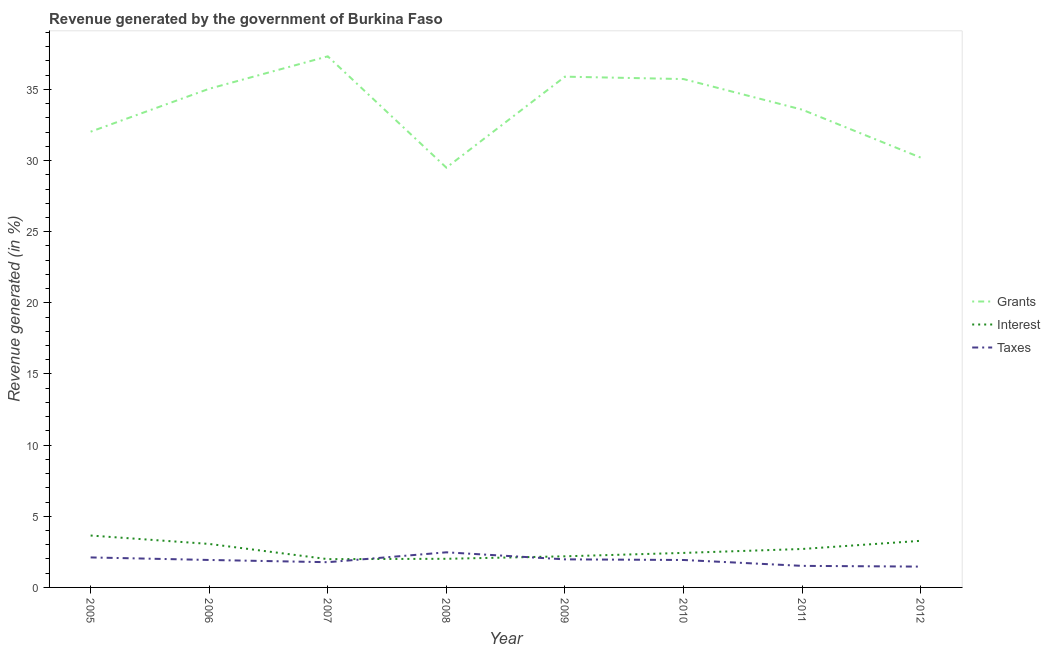How many different coloured lines are there?
Provide a short and direct response. 3. Does the line corresponding to percentage of revenue generated by taxes intersect with the line corresponding to percentage of revenue generated by grants?
Ensure brevity in your answer.  No. What is the percentage of revenue generated by grants in 2005?
Provide a succinct answer. 32.03. Across all years, what is the maximum percentage of revenue generated by taxes?
Ensure brevity in your answer.  2.47. Across all years, what is the minimum percentage of revenue generated by grants?
Make the answer very short. 29.5. In which year was the percentage of revenue generated by interest maximum?
Offer a terse response. 2005. What is the total percentage of revenue generated by taxes in the graph?
Your answer should be compact. 15.16. What is the difference between the percentage of revenue generated by interest in 2006 and that in 2009?
Provide a short and direct response. 0.87. What is the difference between the percentage of revenue generated by grants in 2011 and the percentage of revenue generated by interest in 2006?
Offer a very short reply. 30.52. What is the average percentage of revenue generated by grants per year?
Give a very brief answer. 33.66. In the year 2007, what is the difference between the percentage of revenue generated by interest and percentage of revenue generated by taxes?
Give a very brief answer. 0.21. In how many years, is the percentage of revenue generated by grants greater than 8 %?
Provide a short and direct response. 8. What is the ratio of the percentage of revenue generated by interest in 2010 to that in 2012?
Your answer should be very brief. 0.74. Is the percentage of revenue generated by interest in 2009 less than that in 2010?
Your response must be concise. Yes. Is the difference between the percentage of revenue generated by taxes in 2006 and 2011 greater than the difference between the percentage of revenue generated by interest in 2006 and 2011?
Your response must be concise. Yes. What is the difference between the highest and the second highest percentage of revenue generated by taxes?
Provide a short and direct response. 0.36. What is the difference between the highest and the lowest percentage of revenue generated by taxes?
Keep it short and to the point. 1. Does the percentage of revenue generated by interest monotonically increase over the years?
Ensure brevity in your answer.  No. Is the percentage of revenue generated by taxes strictly greater than the percentage of revenue generated by grants over the years?
Ensure brevity in your answer.  No. Is the percentage of revenue generated by interest strictly less than the percentage of revenue generated by taxes over the years?
Provide a short and direct response. No. How many lines are there?
Provide a short and direct response. 3. What is the difference between two consecutive major ticks on the Y-axis?
Provide a short and direct response. 5. Are the values on the major ticks of Y-axis written in scientific E-notation?
Offer a terse response. No. Does the graph contain grids?
Give a very brief answer. No. Where does the legend appear in the graph?
Offer a very short reply. Center right. How many legend labels are there?
Offer a terse response. 3. How are the legend labels stacked?
Make the answer very short. Vertical. What is the title of the graph?
Offer a terse response. Revenue generated by the government of Burkina Faso. Does "Hydroelectric sources" appear as one of the legend labels in the graph?
Keep it short and to the point. No. What is the label or title of the Y-axis?
Your response must be concise. Revenue generated (in %). What is the Revenue generated (in %) in Grants in 2005?
Provide a succinct answer. 32.03. What is the Revenue generated (in %) in Interest in 2005?
Your response must be concise. 3.65. What is the Revenue generated (in %) in Taxes in 2005?
Your answer should be very brief. 2.11. What is the Revenue generated (in %) of Grants in 2006?
Provide a succinct answer. 35.05. What is the Revenue generated (in %) of Interest in 2006?
Offer a very short reply. 3.06. What is the Revenue generated (in %) in Taxes in 2006?
Your answer should be compact. 1.93. What is the Revenue generated (in %) of Grants in 2007?
Give a very brief answer. 37.32. What is the Revenue generated (in %) of Interest in 2007?
Give a very brief answer. 1.99. What is the Revenue generated (in %) of Taxes in 2007?
Offer a terse response. 1.77. What is the Revenue generated (in %) in Grants in 2008?
Provide a succinct answer. 29.5. What is the Revenue generated (in %) of Interest in 2008?
Your response must be concise. 2.01. What is the Revenue generated (in %) in Taxes in 2008?
Make the answer very short. 2.47. What is the Revenue generated (in %) of Grants in 2009?
Provide a succinct answer. 35.9. What is the Revenue generated (in %) of Interest in 2009?
Provide a succinct answer. 2.19. What is the Revenue generated (in %) in Taxes in 2009?
Make the answer very short. 1.97. What is the Revenue generated (in %) in Grants in 2010?
Ensure brevity in your answer.  35.73. What is the Revenue generated (in %) of Interest in 2010?
Offer a very short reply. 2.43. What is the Revenue generated (in %) of Taxes in 2010?
Your answer should be very brief. 1.93. What is the Revenue generated (in %) in Grants in 2011?
Your answer should be very brief. 33.58. What is the Revenue generated (in %) of Interest in 2011?
Your answer should be very brief. 2.7. What is the Revenue generated (in %) in Taxes in 2011?
Offer a terse response. 1.52. What is the Revenue generated (in %) of Grants in 2012?
Provide a short and direct response. 30.21. What is the Revenue generated (in %) of Interest in 2012?
Make the answer very short. 3.28. What is the Revenue generated (in %) in Taxes in 2012?
Your answer should be very brief. 1.46. Across all years, what is the maximum Revenue generated (in %) in Grants?
Keep it short and to the point. 37.32. Across all years, what is the maximum Revenue generated (in %) of Interest?
Ensure brevity in your answer.  3.65. Across all years, what is the maximum Revenue generated (in %) of Taxes?
Provide a succinct answer. 2.47. Across all years, what is the minimum Revenue generated (in %) of Grants?
Keep it short and to the point. 29.5. Across all years, what is the minimum Revenue generated (in %) of Interest?
Make the answer very short. 1.99. Across all years, what is the minimum Revenue generated (in %) of Taxes?
Make the answer very short. 1.46. What is the total Revenue generated (in %) in Grants in the graph?
Provide a short and direct response. 269.3. What is the total Revenue generated (in %) of Interest in the graph?
Give a very brief answer. 21.29. What is the total Revenue generated (in %) of Taxes in the graph?
Offer a terse response. 15.16. What is the difference between the Revenue generated (in %) in Grants in 2005 and that in 2006?
Keep it short and to the point. -3.02. What is the difference between the Revenue generated (in %) of Interest in 2005 and that in 2006?
Your answer should be compact. 0.59. What is the difference between the Revenue generated (in %) in Taxes in 2005 and that in 2006?
Offer a terse response. 0.18. What is the difference between the Revenue generated (in %) in Grants in 2005 and that in 2007?
Offer a very short reply. -5.3. What is the difference between the Revenue generated (in %) in Interest in 2005 and that in 2007?
Your answer should be very brief. 1.66. What is the difference between the Revenue generated (in %) of Taxes in 2005 and that in 2007?
Give a very brief answer. 0.34. What is the difference between the Revenue generated (in %) in Grants in 2005 and that in 2008?
Give a very brief answer. 2.53. What is the difference between the Revenue generated (in %) of Interest in 2005 and that in 2008?
Make the answer very short. 1.63. What is the difference between the Revenue generated (in %) of Taxes in 2005 and that in 2008?
Provide a short and direct response. -0.36. What is the difference between the Revenue generated (in %) of Grants in 2005 and that in 2009?
Keep it short and to the point. -3.87. What is the difference between the Revenue generated (in %) of Interest in 2005 and that in 2009?
Provide a succinct answer. 1.46. What is the difference between the Revenue generated (in %) in Taxes in 2005 and that in 2009?
Provide a short and direct response. 0.14. What is the difference between the Revenue generated (in %) in Grants in 2005 and that in 2010?
Keep it short and to the point. -3.7. What is the difference between the Revenue generated (in %) of Interest in 2005 and that in 2010?
Provide a succinct answer. 1.22. What is the difference between the Revenue generated (in %) of Taxes in 2005 and that in 2010?
Make the answer very short. 0.18. What is the difference between the Revenue generated (in %) of Grants in 2005 and that in 2011?
Your response must be concise. -1.55. What is the difference between the Revenue generated (in %) of Interest in 2005 and that in 2011?
Provide a short and direct response. 0.95. What is the difference between the Revenue generated (in %) in Taxes in 2005 and that in 2011?
Offer a very short reply. 0.59. What is the difference between the Revenue generated (in %) in Grants in 2005 and that in 2012?
Offer a very short reply. 1.82. What is the difference between the Revenue generated (in %) in Interest in 2005 and that in 2012?
Your response must be concise. 0.37. What is the difference between the Revenue generated (in %) in Taxes in 2005 and that in 2012?
Make the answer very short. 0.65. What is the difference between the Revenue generated (in %) of Grants in 2006 and that in 2007?
Keep it short and to the point. -2.28. What is the difference between the Revenue generated (in %) in Interest in 2006 and that in 2007?
Ensure brevity in your answer.  1.07. What is the difference between the Revenue generated (in %) of Taxes in 2006 and that in 2007?
Provide a succinct answer. 0.16. What is the difference between the Revenue generated (in %) in Grants in 2006 and that in 2008?
Give a very brief answer. 5.55. What is the difference between the Revenue generated (in %) of Interest in 2006 and that in 2008?
Your answer should be very brief. 1.04. What is the difference between the Revenue generated (in %) of Taxes in 2006 and that in 2008?
Provide a succinct answer. -0.54. What is the difference between the Revenue generated (in %) of Grants in 2006 and that in 2009?
Your response must be concise. -0.85. What is the difference between the Revenue generated (in %) in Interest in 2006 and that in 2009?
Offer a terse response. 0.87. What is the difference between the Revenue generated (in %) in Taxes in 2006 and that in 2009?
Provide a short and direct response. -0.04. What is the difference between the Revenue generated (in %) of Grants in 2006 and that in 2010?
Offer a very short reply. -0.68. What is the difference between the Revenue generated (in %) in Interest in 2006 and that in 2010?
Your response must be concise. 0.63. What is the difference between the Revenue generated (in %) in Taxes in 2006 and that in 2010?
Offer a very short reply. 0. What is the difference between the Revenue generated (in %) of Grants in 2006 and that in 2011?
Keep it short and to the point. 1.47. What is the difference between the Revenue generated (in %) of Interest in 2006 and that in 2011?
Make the answer very short. 0.35. What is the difference between the Revenue generated (in %) in Taxes in 2006 and that in 2011?
Offer a terse response. 0.41. What is the difference between the Revenue generated (in %) in Grants in 2006 and that in 2012?
Offer a very short reply. 4.84. What is the difference between the Revenue generated (in %) of Interest in 2006 and that in 2012?
Your answer should be compact. -0.22. What is the difference between the Revenue generated (in %) in Taxes in 2006 and that in 2012?
Your answer should be very brief. 0.47. What is the difference between the Revenue generated (in %) in Grants in 2007 and that in 2008?
Ensure brevity in your answer.  7.82. What is the difference between the Revenue generated (in %) of Interest in 2007 and that in 2008?
Your response must be concise. -0.02. What is the difference between the Revenue generated (in %) of Taxes in 2007 and that in 2008?
Provide a succinct answer. -0.69. What is the difference between the Revenue generated (in %) of Grants in 2007 and that in 2009?
Provide a short and direct response. 1.43. What is the difference between the Revenue generated (in %) of Interest in 2007 and that in 2009?
Keep it short and to the point. -0.2. What is the difference between the Revenue generated (in %) in Taxes in 2007 and that in 2009?
Your answer should be very brief. -0.2. What is the difference between the Revenue generated (in %) in Grants in 2007 and that in 2010?
Make the answer very short. 1.6. What is the difference between the Revenue generated (in %) in Interest in 2007 and that in 2010?
Give a very brief answer. -0.44. What is the difference between the Revenue generated (in %) in Taxes in 2007 and that in 2010?
Offer a very short reply. -0.16. What is the difference between the Revenue generated (in %) in Grants in 2007 and that in 2011?
Offer a terse response. 3.75. What is the difference between the Revenue generated (in %) of Interest in 2007 and that in 2011?
Your response must be concise. -0.71. What is the difference between the Revenue generated (in %) in Taxes in 2007 and that in 2011?
Your response must be concise. 0.26. What is the difference between the Revenue generated (in %) of Grants in 2007 and that in 2012?
Your response must be concise. 7.12. What is the difference between the Revenue generated (in %) of Interest in 2007 and that in 2012?
Offer a very short reply. -1.29. What is the difference between the Revenue generated (in %) in Taxes in 2007 and that in 2012?
Keep it short and to the point. 0.31. What is the difference between the Revenue generated (in %) in Grants in 2008 and that in 2009?
Offer a terse response. -6.39. What is the difference between the Revenue generated (in %) in Interest in 2008 and that in 2009?
Provide a succinct answer. -0.17. What is the difference between the Revenue generated (in %) of Taxes in 2008 and that in 2009?
Your answer should be very brief. 0.49. What is the difference between the Revenue generated (in %) in Grants in 2008 and that in 2010?
Give a very brief answer. -6.23. What is the difference between the Revenue generated (in %) of Interest in 2008 and that in 2010?
Your response must be concise. -0.41. What is the difference between the Revenue generated (in %) in Taxes in 2008 and that in 2010?
Keep it short and to the point. 0.54. What is the difference between the Revenue generated (in %) of Grants in 2008 and that in 2011?
Offer a very short reply. -4.08. What is the difference between the Revenue generated (in %) in Interest in 2008 and that in 2011?
Offer a very short reply. -0.69. What is the difference between the Revenue generated (in %) in Taxes in 2008 and that in 2011?
Offer a terse response. 0.95. What is the difference between the Revenue generated (in %) of Grants in 2008 and that in 2012?
Make the answer very short. -0.71. What is the difference between the Revenue generated (in %) in Interest in 2008 and that in 2012?
Ensure brevity in your answer.  -1.26. What is the difference between the Revenue generated (in %) in Taxes in 2008 and that in 2012?
Keep it short and to the point. 1. What is the difference between the Revenue generated (in %) of Grants in 2009 and that in 2010?
Provide a short and direct response. 0.17. What is the difference between the Revenue generated (in %) of Interest in 2009 and that in 2010?
Your response must be concise. -0.24. What is the difference between the Revenue generated (in %) of Taxes in 2009 and that in 2010?
Your answer should be compact. 0.04. What is the difference between the Revenue generated (in %) of Grants in 2009 and that in 2011?
Give a very brief answer. 2.32. What is the difference between the Revenue generated (in %) of Interest in 2009 and that in 2011?
Provide a succinct answer. -0.51. What is the difference between the Revenue generated (in %) of Taxes in 2009 and that in 2011?
Provide a short and direct response. 0.46. What is the difference between the Revenue generated (in %) of Grants in 2009 and that in 2012?
Keep it short and to the point. 5.69. What is the difference between the Revenue generated (in %) of Interest in 2009 and that in 2012?
Make the answer very short. -1.09. What is the difference between the Revenue generated (in %) of Taxes in 2009 and that in 2012?
Keep it short and to the point. 0.51. What is the difference between the Revenue generated (in %) in Grants in 2010 and that in 2011?
Provide a succinct answer. 2.15. What is the difference between the Revenue generated (in %) of Interest in 2010 and that in 2011?
Your response must be concise. -0.28. What is the difference between the Revenue generated (in %) of Taxes in 2010 and that in 2011?
Provide a short and direct response. 0.41. What is the difference between the Revenue generated (in %) of Grants in 2010 and that in 2012?
Make the answer very short. 5.52. What is the difference between the Revenue generated (in %) in Interest in 2010 and that in 2012?
Offer a terse response. -0.85. What is the difference between the Revenue generated (in %) in Taxes in 2010 and that in 2012?
Ensure brevity in your answer.  0.47. What is the difference between the Revenue generated (in %) of Grants in 2011 and that in 2012?
Your response must be concise. 3.37. What is the difference between the Revenue generated (in %) in Interest in 2011 and that in 2012?
Your answer should be very brief. -0.57. What is the difference between the Revenue generated (in %) of Taxes in 2011 and that in 2012?
Make the answer very short. 0.05. What is the difference between the Revenue generated (in %) of Grants in 2005 and the Revenue generated (in %) of Interest in 2006?
Provide a succinct answer. 28.97. What is the difference between the Revenue generated (in %) in Grants in 2005 and the Revenue generated (in %) in Taxes in 2006?
Your response must be concise. 30.1. What is the difference between the Revenue generated (in %) of Interest in 2005 and the Revenue generated (in %) of Taxes in 2006?
Offer a very short reply. 1.72. What is the difference between the Revenue generated (in %) of Grants in 2005 and the Revenue generated (in %) of Interest in 2007?
Ensure brevity in your answer.  30.04. What is the difference between the Revenue generated (in %) of Grants in 2005 and the Revenue generated (in %) of Taxes in 2007?
Your answer should be very brief. 30.25. What is the difference between the Revenue generated (in %) in Interest in 2005 and the Revenue generated (in %) in Taxes in 2007?
Your response must be concise. 1.87. What is the difference between the Revenue generated (in %) in Grants in 2005 and the Revenue generated (in %) in Interest in 2008?
Your answer should be compact. 30.02. What is the difference between the Revenue generated (in %) of Grants in 2005 and the Revenue generated (in %) of Taxes in 2008?
Your response must be concise. 29.56. What is the difference between the Revenue generated (in %) of Interest in 2005 and the Revenue generated (in %) of Taxes in 2008?
Provide a short and direct response. 1.18. What is the difference between the Revenue generated (in %) of Grants in 2005 and the Revenue generated (in %) of Interest in 2009?
Keep it short and to the point. 29.84. What is the difference between the Revenue generated (in %) of Grants in 2005 and the Revenue generated (in %) of Taxes in 2009?
Keep it short and to the point. 30.05. What is the difference between the Revenue generated (in %) in Interest in 2005 and the Revenue generated (in %) in Taxes in 2009?
Your answer should be compact. 1.67. What is the difference between the Revenue generated (in %) of Grants in 2005 and the Revenue generated (in %) of Interest in 2010?
Your answer should be very brief. 29.6. What is the difference between the Revenue generated (in %) of Grants in 2005 and the Revenue generated (in %) of Taxes in 2010?
Provide a succinct answer. 30.1. What is the difference between the Revenue generated (in %) in Interest in 2005 and the Revenue generated (in %) in Taxes in 2010?
Make the answer very short. 1.72. What is the difference between the Revenue generated (in %) in Grants in 2005 and the Revenue generated (in %) in Interest in 2011?
Your answer should be compact. 29.33. What is the difference between the Revenue generated (in %) of Grants in 2005 and the Revenue generated (in %) of Taxes in 2011?
Provide a succinct answer. 30.51. What is the difference between the Revenue generated (in %) of Interest in 2005 and the Revenue generated (in %) of Taxes in 2011?
Keep it short and to the point. 2.13. What is the difference between the Revenue generated (in %) in Grants in 2005 and the Revenue generated (in %) in Interest in 2012?
Give a very brief answer. 28.75. What is the difference between the Revenue generated (in %) of Grants in 2005 and the Revenue generated (in %) of Taxes in 2012?
Give a very brief answer. 30.56. What is the difference between the Revenue generated (in %) of Interest in 2005 and the Revenue generated (in %) of Taxes in 2012?
Give a very brief answer. 2.18. What is the difference between the Revenue generated (in %) of Grants in 2006 and the Revenue generated (in %) of Interest in 2007?
Ensure brevity in your answer.  33.06. What is the difference between the Revenue generated (in %) of Grants in 2006 and the Revenue generated (in %) of Taxes in 2007?
Ensure brevity in your answer.  33.27. What is the difference between the Revenue generated (in %) in Interest in 2006 and the Revenue generated (in %) in Taxes in 2007?
Provide a short and direct response. 1.28. What is the difference between the Revenue generated (in %) in Grants in 2006 and the Revenue generated (in %) in Interest in 2008?
Provide a succinct answer. 33.03. What is the difference between the Revenue generated (in %) of Grants in 2006 and the Revenue generated (in %) of Taxes in 2008?
Give a very brief answer. 32.58. What is the difference between the Revenue generated (in %) of Interest in 2006 and the Revenue generated (in %) of Taxes in 2008?
Provide a short and direct response. 0.59. What is the difference between the Revenue generated (in %) in Grants in 2006 and the Revenue generated (in %) in Interest in 2009?
Offer a terse response. 32.86. What is the difference between the Revenue generated (in %) in Grants in 2006 and the Revenue generated (in %) in Taxes in 2009?
Make the answer very short. 33.07. What is the difference between the Revenue generated (in %) of Interest in 2006 and the Revenue generated (in %) of Taxes in 2009?
Your response must be concise. 1.08. What is the difference between the Revenue generated (in %) of Grants in 2006 and the Revenue generated (in %) of Interest in 2010?
Your answer should be very brief. 32.62. What is the difference between the Revenue generated (in %) in Grants in 2006 and the Revenue generated (in %) in Taxes in 2010?
Ensure brevity in your answer.  33.12. What is the difference between the Revenue generated (in %) of Interest in 2006 and the Revenue generated (in %) of Taxes in 2010?
Keep it short and to the point. 1.13. What is the difference between the Revenue generated (in %) in Grants in 2006 and the Revenue generated (in %) in Interest in 2011?
Keep it short and to the point. 32.34. What is the difference between the Revenue generated (in %) in Grants in 2006 and the Revenue generated (in %) in Taxes in 2011?
Make the answer very short. 33.53. What is the difference between the Revenue generated (in %) in Interest in 2006 and the Revenue generated (in %) in Taxes in 2011?
Provide a succinct answer. 1.54. What is the difference between the Revenue generated (in %) of Grants in 2006 and the Revenue generated (in %) of Interest in 2012?
Your answer should be compact. 31.77. What is the difference between the Revenue generated (in %) in Grants in 2006 and the Revenue generated (in %) in Taxes in 2012?
Offer a very short reply. 33.58. What is the difference between the Revenue generated (in %) in Interest in 2006 and the Revenue generated (in %) in Taxes in 2012?
Give a very brief answer. 1.59. What is the difference between the Revenue generated (in %) in Grants in 2007 and the Revenue generated (in %) in Interest in 2008?
Offer a terse response. 35.31. What is the difference between the Revenue generated (in %) in Grants in 2007 and the Revenue generated (in %) in Taxes in 2008?
Offer a terse response. 34.86. What is the difference between the Revenue generated (in %) in Interest in 2007 and the Revenue generated (in %) in Taxes in 2008?
Make the answer very short. -0.48. What is the difference between the Revenue generated (in %) in Grants in 2007 and the Revenue generated (in %) in Interest in 2009?
Provide a succinct answer. 35.14. What is the difference between the Revenue generated (in %) in Grants in 2007 and the Revenue generated (in %) in Taxes in 2009?
Provide a short and direct response. 35.35. What is the difference between the Revenue generated (in %) in Interest in 2007 and the Revenue generated (in %) in Taxes in 2009?
Your answer should be very brief. 0.01. What is the difference between the Revenue generated (in %) of Grants in 2007 and the Revenue generated (in %) of Interest in 2010?
Keep it short and to the point. 34.9. What is the difference between the Revenue generated (in %) of Grants in 2007 and the Revenue generated (in %) of Taxes in 2010?
Your answer should be compact. 35.4. What is the difference between the Revenue generated (in %) of Interest in 2007 and the Revenue generated (in %) of Taxes in 2010?
Your answer should be compact. 0.06. What is the difference between the Revenue generated (in %) of Grants in 2007 and the Revenue generated (in %) of Interest in 2011?
Ensure brevity in your answer.  34.62. What is the difference between the Revenue generated (in %) in Grants in 2007 and the Revenue generated (in %) in Taxes in 2011?
Your response must be concise. 35.81. What is the difference between the Revenue generated (in %) in Interest in 2007 and the Revenue generated (in %) in Taxes in 2011?
Provide a succinct answer. 0.47. What is the difference between the Revenue generated (in %) of Grants in 2007 and the Revenue generated (in %) of Interest in 2012?
Your answer should be compact. 34.05. What is the difference between the Revenue generated (in %) of Grants in 2007 and the Revenue generated (in %) of Taxes in 2012?
Give a very brief answer. 35.86. What is the difference between the Revenue generated (in %) of Interest in 2007 and the Revenue generated (in %) of Taxes in 2012?
Offer a very short reply. 0.52. What is the difference between the Revenue generated (in %) of Grants in 2008 and the Revenue generated (in %) of Interest in 2009?
Your answer should be very brief. 27.31. What is the difference between the Revenue generated (in %) in Grants in 2008 and the Revenue generated (in %) in Taxes in 2009?
Make the answer very short. 27.53. What is the difference between the Revenue generated (in %) in Interest in 2008 and the Revenue generated (in %) in Taxes in 2009?
Offer a terse response. 0.04. What is the difference between the Revenue generated (in %) of Grants in 2008 and the Revenue generated (in %) of Interest in 2010?
Provide a succinct answer. 27.07. What is the difference between the Revenue generated (in %) in Grants in 2008 and the Revenue generated (in %) in Taxes in 2010?
Keep it short and to the point. 27.57. What is the difference between the Revenue generated (in %) in Interest in 2008 and the Revenue generated (in %) in Taxes in 2010?
Your answer should be compact. 0.08. What is the difference between the Revenue generated (in %) of Grants in 2008 and the Revenue generated (in %) of Interest in 2011?
Give a very brief answer. 26.8. What is the difference between the Revenue generated (in %) of Grants in 2008 and the Revenue generated (in %) of Taxes in 2011?
Keep it short and to the point. 27.99. What is the difference between the Revenue generated (in %) of Interest in 2008 and the Revenue generated (in %) of Taxes in 2011?
Give a very brief answer. 0.5. What is the difference between the Revenue generated (in %) of Grants in 2008 and the Revenue generated (in %) of Interest in 2012?
Your answer should be very brief. 26.23. What is the difference between the Revenue generated (in %) in Grants in 2008 and the Revenue generated (in %) in Taxes in 2012?
Keep it short and to the point. 28.04. What is the difference between the Revenue generated (in %) in Interest in 2008 and the Revenue generated (in %) in Taxes in 2012?
Keep it short and to the point. 0.55. What is the difference between the Revenue generated (in %) in Grants in 2009 and the Revenue generated (in %) in Interest in 2010?
Your response must be concise. 33.47. What is the difference between the Revenue generated (in %) in Grants in 2009 and the Revenue generated (in %) in Taxes in 2010?
Offer a very short reply. 33.97. What is the difference between the Revenue generated (in %) of Interest in 2009 and the Revenue generated (in %) of Taxes in 2010?
Offer a terse response. 0.26. What is the difference between the Revenue generated (in %) in Grants in 2009 and the Revenue generated (in %) in Interest in 2011?
Keep it short and to the point. 33.19. What is the difference between the Revenue generated (in %) of Grants in 2009 and the Revenue generated (in %) of Taxes in 2011?
Offer a terse response. 34.38. What is the difference between the Revenue generated (in %) of Interest in 2009 and the Revenue generated (in %) of Taxes in 2011?
Offer a very short reply. 0.67. What is the difference between the Revenue generated (in %) in Grants in 2009 and the Revenue generated (in %) in Interest in 2012?
Provide a short and direct response. 32.62. What is the difference between the Revenue generated (in %) of Grants in 2009 and the Revenue generated (in %) of Taxes in 2012?
Keep it short and to the point. 34.43. What is the difference between the Revenue generated (in %) of Interest in 2009 and the Revenue generated (in %) of Taxes in 2012?
Give a very brief answer. 0.72. What is the difference between the Revenue generated (in %) in Grants in 2010 and the Revenue generated (in %) in Interest in 2011?
Provide a succinct answer. 33.02. What is the difference between the Revenue generated (in %) in Grants in 2010 and the Revenue generated (in %) in Taxes in 2011?
Your answer should be compact. 34.21. What is the difference between the Revenue generated (in %) of Interest in 2010 and the Revenue generated (in %) of Taxes in 2011?
Provide a short and direct response. 0.91. What is the difference between the Revenue generated (in %) in Grants in 2010 and the Revenue generated (in %) in Interest in 2012?
Keep it short and to the point. 32.45. What is the difference between the Revenue generated (in %) in Grants in 2010 and the Revenue generated (in %) in Taxes in 2012?
Your answer should be very brief. 34.26. What is the difference between the Revenue generated (in %) in Interest in 2010 and the Revenue generated (in %) in Taxes in 2012?
Offer a very short reply. 0.96. What is the difference between the Revenue generated (in %) of Grants in 2011 and the Revenue generated (in %) of Interest in 2012?
Make the answer very short. 30.3. What is the difference between the Revenue generated (in %) of Grants in 2011 and the Revenue generated (in %) of Taxes in 2012?
Offer a terse response. 32.11. What is the difference between the Revenue generated (in %) in Interest in 2011 and the Revenue generated (in %) in Taxes in 2012?
Offer a terse response. 1.24. What is the average Revenue generated (in %) of Grants per year?
Keep it short and to the point. 33.66. What is the average Revenue generated (in %) in Interest per year?
Make the answer very short. 2.66. What is the average Revenue generated (in %) in Taxes per year?
Make the answer very short. 1.89. In the year 2005, what is the difference between the Revenue generated (in %) of Grants and Revenue generated (in %) of Interest?
Provide a succinct answer. 28.38. In the year 2005, what is the difference between the Revenue generated (in %) in Grants and Revenue generated (in %) in Taxes?
Keep it short and to the point. 29.92. In the year 2005, what is the difference between the Revenue generated (in %) of Interest and Revenue generated (in %) of Taxes?
Make the answer very short. 1.54. In the year 2006, what is the difference between the Revenue generated (in %) in Grants and Revenue generated (in %) in Interest?
Offer a very short reply. 31.99. In the year 2006, what is the difference between the Revenue generated (in %) in Grants and Revenue generated (in %) in Taxes?
Provide a succinct answer. 33.12. In the year 2006, what is the difference between the Revenue generated (in %) in Interest and Revenue generated (in %) in Taxes?
Keep it short and to the point. 1.13. In the year 2007, what is the difference between the Revenue generated (in %) of Grants and Revenue generated (in %) of Interest?
Keep it short and to the point. 35.34. In the year 2007, what is the difference between the Revenue generated (in %) in Grants and Revenue generated (in %) in Taxes?
Provide a succinct answer. 35.55. In the year 2007, what is the difference between the Revenue generated (in %) in Interest and Revenue generated (in %) in Taxes?
Provide a short and direct response. 0.21. In the year 2008, what is the difference between the Revenue generated (in %) in Grants and Revenue generated (in %) in Interest?
Give a very brief answer. 27.49. In the year 2008, what is the difference between the Revenue generated (in %) of Grants and Revenue generated (in %) of Taxes?
Provide a succinct answer. 27.03. In the year 2008, what is the difference between the Revenue generated (in %) in Interest and Revenue generated (in %) in Taxes?
Your response must be concise. -0.46. In the year 2009, what is the difference between the Revenue generated (in %) in Grants and Revenue generated (in %) in Interest?
Provide a short and direct response. 33.71. In the year 2009, what is the difference between the Revenue generated (in %) of Grants and Revenue generated (in %) of Taxes?
Your answer should be very brief. 33.92. In the year 2009, what is the difference between the Revenue generated (in %) of Interest and Revenue generated (in %) of Taxes?
Keep it short and to the point. 0.21. In the year 2010, what is the difference between the Revenue generated (in %) of Grants and Revenue generated (in %) of Interest?
Your response must be concise. 33.3. In the year 2010, what is the difference between the Revenue generated (in %) in Grants and Revenue generated (in %) in Taxes?
Make the answer very short. 33.8. In the year 2010, what is the difference between the Revenue generated (in %) in Interest and Revenue generated (in %) in Taxes?
Provide a succinct answer. 0.5. In the year 2011, what is the difference between the Revenue generated (in %) of Grants and Revenue generated (in %) of Interest?
Your answer should be compact. 30.88. In the year 2011, what is the difference between the Revenue generated (in %) of Grants and Revenue generated (in %) of Taxes?
Your answer should be compact. 32.06. In the year 2011, what is the difference between the Revenue generated (in %) in Interest and Revenue generated (in %) in Taxes?
Your answer should be very brief. 1.19. In the year 2012, what is the difference between the Revenue generated (in %) in Grants and Revenue generated (in %) in Interest?
Keep it short and to the point. 26.93. In the year 2012, what is the difference between the Revenue generated (in %) of Grants and Revenue generated (in %) of Taxes?
Offer a terse response. 28.74. In the year 2012, what is the difference between the Revenue generated (in %) in Interest and Revenue generated (in %) in Taxes?
Your answer should be very brief. 1.81. What is the ratio of the Revenue generated (in %) in Grants in 2005 to that in 2006?
Provide a succinct answer. 0.91. What is the ratio of the Revenue generated (in %) in Interest in 2005 to that in 2006?
Offer a very short reply. 1.19. What is the ratio of the Revenue generated (in %) of Taxes in 2005 to that in 2006?
Keep it short and to the point. 1.09. What is the ratio of the Revenue generated (in %) of Grants in 2005 to that in 2007?
Keep it short and to the point. 0.86. What is the ratio of the Revenue generated (in %) in Interest in 2005 to that in 2007?
Offer a terse response. 1.83. What is the ratio of the Revenue generated (in %) of Taxes in 2005 to that in 2007?
Ensure brevity in your answer.  1.19. What is the ratio of the Revenue generated (in %) in Grants in 2005 to that in 2008?
Provide a succinct answer. 1.09. What is the ratio of the Revenue generated (in %) in Interest in 2005 to that in 2008?
Give a very brief answer. 1.81. What is the ratio of the Revenue generated (in %) in Taxes in 2005 to that in 2008?
Keep it short and to the point. 0.85. What is the ratio of the Revenue generated (in %) of Grants in 2005 to that in 2009?
Make the answer very short. 0.89. What is the ratio of the Revenue generated (in %) in Interest in 2005 to that in 2009?
Your response must be concise. 1.67. What is the ratio of the Revenue generated (in %) of Taxes in 2005 to that in 2009?
Provide a succinct answer. 1.07. What is the ratio of the Revenue generated (in %) in Grants in 2005 to that in 2010?
Give a very brief answer. 0.9. What is the ratio of the Revenue generated (in %) of Interest in 2005 to that in 2010?
Ensure brevity in your answer.  1.5. What is the ratio of the Revenue generated (in %) of Taxes in 2005 to that in 2010?
Make the answer very short. 1.09. What is the ratio of the Revenue generated (in %) of Grants in 2005 to that in 2011?
Ensure brevity in your answer.  0.95. What is the ratio of the Revenue generated (in %) in Interest in 2005 to that in 2011?
Your answer should be very brief. 1.35. What is the ratio of the Revenue generated (in %) in Taxes in 2005 to that in 2011?
Keep it short and to the point. 1.39. What is the ratio of the Revenue generated (in %) of Grants in 2005 to that in 2012?
Offer a terse response. 1.06. What is the ratio of the Revenue generated (in %) in Interest in 2005 to that in 2012?
Make the answer very short. 1.11. What is the ratio of the Revenue generated (in %) of Taxes in 2005 to that in 2012?
Provide a succinct answer. 1.44. What is the ratio of the Revenue generated (in %) in Grants in 2006 to that in 2007?
Keep it short and to the point. 0.94. What is the ratio of the Revenue generated (in %) in Interest in 2006 to that in 2007?
Offer a terse response. 1.54. What is the ratio of the Revenue generated (in %) of Taxes in 2006 to that in 2007?
Provide a succinct answer. 1.09. What is the ratio of the Revenue generated (in %) in Grants in 2006 to that in 2008?
Provide a succinct answer. 1.19. What is the ratio of the Revenue generated (in %) in Interest in 2006 to that in 2008?
Keep it short and to the point. 1.52. What is the ratio of the Revenue generated (in %) of Taxes in 2006 to that in 2008?
Offer a terse response. 0.78. What is the ratio of the Revenue generated (in %) of Grants in 2006 to that in 2009?
Provide a short and direct response. 0.98. What is the ratio of the Revenue generated (in %) of Interest in 2006 to that in 2009?
Offer a terse response. 1.4. What is the ratio of the Revenue generated (in %) in Taxes in 2006 to that in 2009?
Make the answer very short. 0.98. What is the ratio of the Revenue generated (in %) of Interest in 2006 to that in 2010?
Provide a succinct answer. 1.26. What is the ratio of the Revenue generated (in %) in Grants in 2006 to that in 2011?
Give a very brief answer. 1.04. What is the ratio of the Revenue generated (in %) in Interest in 2006 to that in 2011?
Ensure brevity in your answer.  1.13. What is the ratio of the Revenue generated (in %) of Taxes in 2006 to that in 2011?
Give a very brief answer. 1.27. What is the ratio of the Revenue generated (in %) in Grants in 2006 to that in 2012?
Make the answer very short. 1.16. What is the ratio of the Revenue generated (in %) in Interest in 2006 to that in 2012?
Ensure brevity in your answer.  0.93. What is the ratio of the Revenue generated (in %) of Taxes in 2006 to that in 2012?
Your response must be concise. 1.32. What is the ratio of the Revenue generated (in %) of Grants in 2007 to that in 2008?
Ensure brevity in your answer.  1.27. What is the ratio of the Revenue generated (in %) of Interest in 2007 to that in 2008?
Ensure brevity in your answer.  0.99. What is the ratio of the Revenue generated (in %) of Taxes in 2007 to that in 2008?
Keep it short and to the point. 0.72. What is the ratio of the Revenue generated (in %) in Grants in 2007 to that in 2009?
Your response must be concise. 1.04. What is the ratio of the Revenue generated (in %) in Interest in 2007 to that in 2009?
Offer a terse response. 0.91. What is the ratio of the Revenue generated (in %) of Taxes in 2007 to that in 2009?
Provide a succinct answer. 0.9. What is the ratio of the Revenue generated (in %) in Grants in 2007 to that in 2010?
Make the answer very short. 1.04. What is the ratio of the Revenue generated (in %) of Interest in 2007 to that in 2010?
Keep it short and to the point. 0.82. What is the ratio of the Revenue generated (in %) of Taxes in 2007 to that in 2010?
Provide a short and direct response. 0.92. What is the ratio of the Revenue generated (in %) in Grants in 2007 to that in 2011?
Offer a terse response. 1.11. What is the ratio of the Revenue generated (in %) of Interest in 2007 to that in 2011?
Keep it short and to the point. 0.74. What is the ratio of the Revenue generated (in %) of Taxes in 2007 to that in 2011?
Ensure brevity in your answer.  1.17. What is the ratio of the Revenue generated (in %) in Grants in 2007 to that in 2012?
Make the answer very short. 1.24. What is the ratio of the Revenue generated (in %) in Interest in 2007 to that in 2012?
Offer a terse response. 0.61. What is the ratio of the Revenue generated (in %) in Taxes in 2007 to that in 2012?
Offer a terse response. 1.21. What is the ratio of the Revenue generated (in %) of Grants in 2008 to that in 2009?
Give a very brief answer. 0.82. What is the ratio of the Revenue generated (in %) in Interest in 2008 to that in 2009?
Offer a terse response. 0.92. What is the ratio of the Revenue generated (in %) of Taxes in 2008 to that in 2009?
Offer a very short reply. 1.25. What is the ratio of the Revenue generated (in %) of Grants in 2008 to that in 2010?
Keep it short and to the point. 0.83. What is the ratio of the Revenue generated (in %) in Interest in 2008 to that in 2010?
Offer a terse response. 0.83. What is the ratio of the Revenue generated (in %) of Taxes in 2008 to that in 2010?
Provide a succinct answer. 1.28. What is the ratio of the Revenue generated (in %) of Grants in 2008 to that in 2011?
Make the answer very short. 0.88. What is the ratio of the Revenue generated (in %) in Interest in 2008 to that in 2011?
Provide a succinct answer. 0.74. What is the ratio of the Revenue generated (in %) in Taxes in 2008 to that in 2011?
Your answer should be very brief. 1.63. What is the ratio of the Revenue generated (in %) of Grants in 2008 to that in 2012?
Ensure brevity in your answer.  0.98. What is the ratio of the Revenue generated (in %) in Interest in 2008 to that in 2012?
Your response must be concise. 0.61. What is the ratio of the Revenue generated (in %) of Taxes in 2008 to that in 2012?
Make the answer very short. 1.69. What is the ratio of the Revenue generated (in %) of Interest in 2009 to that in 2010?
Offer a terse response. 0.9. What is the ratio of the Revenue generated (in %) of Taxes in 2009 to that in 2010?
Make the answer very short. 1.02. What is the ratio of the Revenue generated (in %) of Grants in 2009 to that in 2011?
Your response must be concise. 1.07. What is the ratio of the Revenue generated (in %) of Interest in 2009 to that in 2011?
Make the answer very short. 0.81. What is the ratio of the Revenue generated (in %) of Taxes in 2009 to that in 2011?
Make the answer very short. 1.3. What is the ratio of the Revenue generated (in %) of Grants in 2009 to that in 2012?
Your answer should be very brief. 1.19. What is the ratio of the Revenue generated (in %) in Interest in 2009 to that in 2012?
Make the answer very short. 0.67. What is the ratio of the Revenue generated (in %) of Taxes in 2009 to that in 2012?
Offer a very short reply. 1.35. What is the ratio of the Revenue generated (in %) of Grants in 2010 to that in 2011?
Provide a succinct answer. 1.06. What is the ratio of the Revenue generated (in %) in Interest in 2010 to that in 2011?
Keep it short and to the point. 0.9. What is the ratio of the Revenue generated (in %) of Taxes in 2010 to that in 2011?
Offer a terse response. 1.27. What is the ratio of the Revenue generated (in %) in Grants in 2010 to that in 2012?
Offer a terse response. 1.18. What is the ratio of the Revenue generated (in %) in Interest in 2010 to that in 2012?
Provide a short and direct response. 0.74. What is the ratio of the Revenue generated (in %) in Taxes in 2010 to that in 2012?
Make the answer very short. 1.32. What is the ratio of the Revenue generated (in %) in Grants in 2011 to that in 2012?
Ensure brevity in your answer.  1.11. What is the ratio of the Revenue generated (in %) in Interest in 2011 to that in 2012?
Offer a very short reply. 0.82. What is the ratio of the Revenue generated (in %) of Taxes in 2011 to that in 2012?
Give a very brief answer. 1.04. What is the difference between the highest and the second highest Revenue generated (in %) in Grants?
Your answer should be very brief. 1.43. What is the difference between the highest and the second highest Revenue generated (in %) of Interest?
Your answer should be very brief. 0.37. What is the difference between the highest and the second highest Revenue generated (in %) in Taxes?
Offer a terse response. 0.36. What is the difference between the highest and the lowest Revenue generated (in %) of Grants?
Keep it short and to the point. 7.82. What is the difference between the highest and the lowest Revenue generated (in %) of Interest?
Your answer should be very brief. 1.66. What is the difference between the highest and the lowest Revenue generated (in %) in Taxes?
Ensure brevity in your answer.  1. 